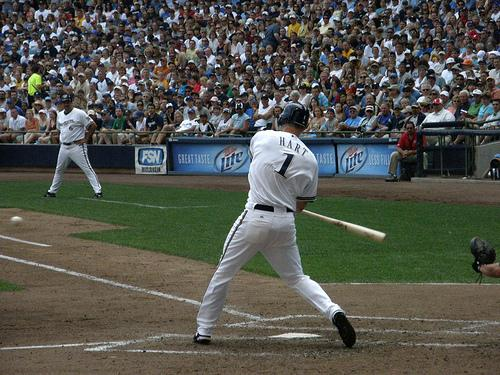According to the banner ad what kind of Lite beer tastes great? miller 